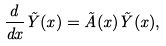<formula> <loc_0><loc_0><loc_500><loc_500>\frac { d } { d x } \tilde { Y } ( x ) = \tilde { A } ( x ) \tilde { Y } ( x ) ,</formula> 